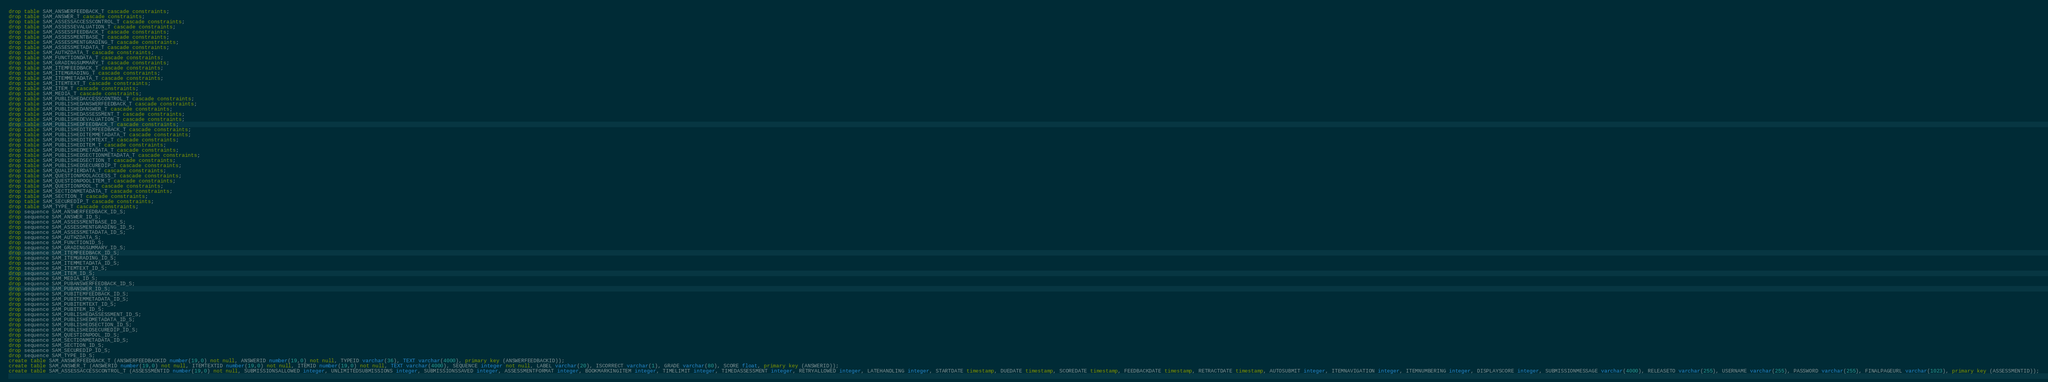<code> <loc_0><loc_0><loc_500><loc_500><_SQL_>drop table SAM_ANSWERFEEDBACK_T cascade constraints;
drop table SAM_ANSWER_T cascade constraints;
drop table SAM_ASSESSACCESSCONTROL_T cascade constraints;
drop table SAM_ASSESSEVALUATION_T cascade constraints;
drop table SAM_ASSESSFEEDBACK_T cascade constraints;
drop table SAM_ASSESSMENTBASE_T cascade constraints;
drop table SAM_ASSESSMENTGRADING_T cascade constraints;
drop table SAM_ASSESSMETADATA_T cascade constraints;
drop table SAM_AUTHZDATA_T cascade constraints;
drop table SAM_FUNCTIONDATA_T cascade constraints;
drop table SAM_GRADINGSUMMARY_T cascade constraints;
drop table SAM_ITEMFEEDBACK_T cascade constraints;
drop table SAM_ITEMGRADING_T cascade constraints;
drop table SAM_ITEMMETADATA_T cascade constraints;
drop table SAM_ITEMTEXT_T cascade constraints;
drop table SAM_ITEM_T cascade constraints;
drop table SAM_MEDIA_T cascade constraints;
drop table SAM_PUBLISHEDACCESSCONTROL_T cascade constraints;
drop table SAM_PUBLISHEDANSWERFEEDBACK_T cascade constraints;
drop table SAM_PUBLISHEDANSWER_T cascade constraints;
drop table SAM_PUBLISHEDASSESSMENT_T cascade constraints;
drop table SAM_PUBLISHEDEVALUATION_T cascade constraints;
drop table SAM_PUBLISHEDFEEDBACK_T cascade constraints;
drop table SAM_PUBLISHEDITEMFEEDBACK_T cascade constraints;
drop table SAM_PUBLISHEDITEMMETADATA_T cascade constraints;
drop table SAM_PUBLISHEDITEMTEXT_T cascade constraints;
drop table SAM_PUBLISHEDITEM_T cascade constraints;
drop table SAM_PUBLISHEDMETADATA_T cascade constraints;
drop table SAM_PUBLISHEDSECTIONMETADATA_T cascade constraints;
drop table SAM_PUBLISHEDSECTION_T cascade constraints;
drop table SAM_PUBLISHEDSECUREDIP_T cascade constraints;
drop table SAM_QUALIFIERDATA_T cascade constraints;
drop table SAM_QUESTIONPOOLACCESS_T cascade constraints;
drop table SAM_QUESTIONPOOLITEM_T cascade constraints;
drop table SAM_QUESTIONPOOL_T cascade constraints;
drop table SAM_SECTIONMETADATA_T cascade constraints;
drop table SAM_SECTION_T cascade constraints;
drop table SAM_SECUREDIP_T cascade constraints;
drop table SAM_TYPE_T cascade constraints;
drop sequence SAM_ANSWERFEEDBACK_ID_S;
drop sequence SAM_ANSWER_ID_S;
drop sequence SAM_ASSESSMENTBASE_ID_S;
drop sequence SAM_ASSESSMENTGRADING_ID_S;
drop sequence SAM_ASSESSMETADATA_ID_S;
drop sequence SAM_AUTHZDATA_S;
drop sequence SAM_FUNCTIONID_S;
drop sequence SAM_GRADINGSUMMARY_ID_S;
drop sequence SAM_ITEMFEEDBACK_ID_S;
drop sequence SAM_ITEMGRADING_ID_S;
drop sequence SAM_ITEMMETADATA_ID_S;
drop sequence SAM_ITEMTEXT_ID_S;
drop sequence SAM_ITEM_ID_S;
drop sequence SAM_MEDIA_ID_S;
drop sequence SAM_PUBANSWERFEEDBACK_ID_S;
drop sequence SAM_PUBANSWER_ID_S;
drop sequence SAM_PUBITEMFEEDBACK_ID_S;
drop sequence SAM_PUBITEMMETADATA_ID_S;
drop sequence SAM_PUBITEMTEXT_ID_S;
drop sequence SAM_PUBITEM_ID_S;
drop sequence SAM_PUBLISHEDASSESSMENT_ID_S;
drop sequence SAM_PUBLISHEDMETADATA_ID_S;
drop sequence SAM_PUBLISHEDSECTION_ID_S;
drop sequence SAM_PUBLISHEDSECUREDIP_ID_S;
drop sequence SAM_QUESTIONPOOL_ID_S;
drop sequence SAM_SECTIONMETADATA_ID_S;
drop sequence SAM_SECTION_ID_S;
drop sequence SAM_SECUREDIP_ID_S;
drop sequence SAM_TYPE_ID_S;
create table SAM_ANSWERFEEDBACK_T (ANSWERFEEDBACKID number(19,0) not null, ANSWERID number(19,0) not null, TYPEID varchar(36), TEXT varchar(4000), primary key (ANSWERFEEDBACKID));
create table SAM_ANSWER_T (ANSWERID number(19,0) not null, ITEMTEXTID number(19,0) not null, ITEMID number(19,0) not null, TEXT varchar(4000), SEQUENCE integer not null, LABEL varchar(20), ISCORRECT varchar(1), GRADE varchar(80), SCORE float, primary key (ANSWERID));
create table SAM_ASSESSACCESSCONTROL_T (ASSESSMENTID number(19,0) not null, SUBMISSIONSALLOWED integer, UNLIMITEDSUBMISSIONS integer, SUBMISSIONSSAVED integer, ASSESSMENTFORMAT integer, BOOKMARKINGITEM integer, TIMELIMIT integer, TIMEDASSESSMENT integer, RETRYALLOWED integer, LATEHANDLING integer, STARTDATE timestamp, DUEDATE timestamp, SCOREDATE timestamp, FEEDBACKDATE timestamp, RETRACTDATE timestamp, AUTOSUBMIT integer, ITEMNAVIGATION integer, ITEMNUMBERING integer, DISPLAYSCORE integer, SUBMISSIONMESSAGE varchar(4000), RELEASETO varchar(255), USERNAME varchar(255), PASSWORD varchar(255), FINALPAGEURL varchar(1023), primary key (ASSESSMENTID));</code> 